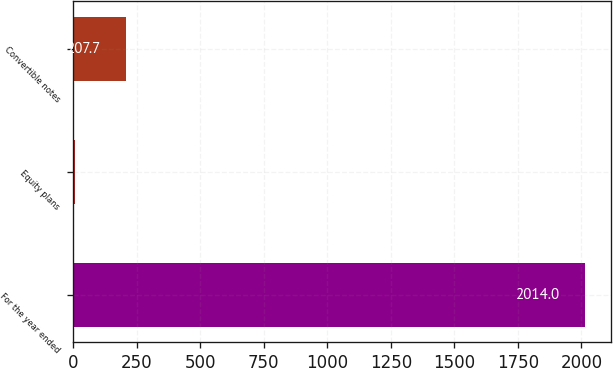<chart> <loc_0><loc_0><loc_500><loc_500><bar_chart><fcel>For the year ended<fcel>Equity plans<fcel>Convertible notes<nl><fcel>2014<fcel>7<fcel>207.7<nl></chart> 